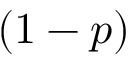<formula> <loc_0><loc_0><loc_500><loc_500>( 1 - p )</formula> 